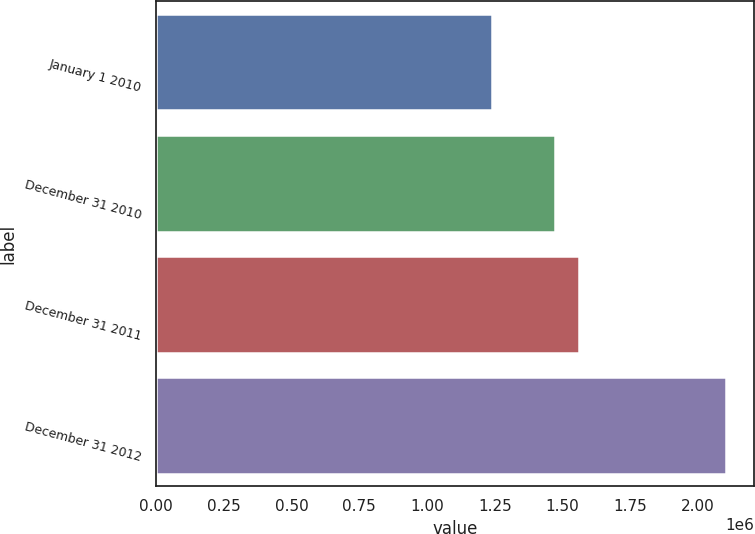<chart> <loc_0><loc_0><loc_500><loc_500><bar_chart><fcel>January 1 2010<fcel>December 31 2010<fcel>December 31 2011<fcel>December 31 2012<nl><fcel>1.23827e+06<fcel>1.47222e+06<fcel>1.56116e+06<fcel>2.10284e+06<nl></chart> 